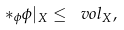<formula> <loc_0><loc_0><loc_500><loc_500>* _ { \phi } \phi | _ { X } \leq \ v o l _ { X } ,</formula> 